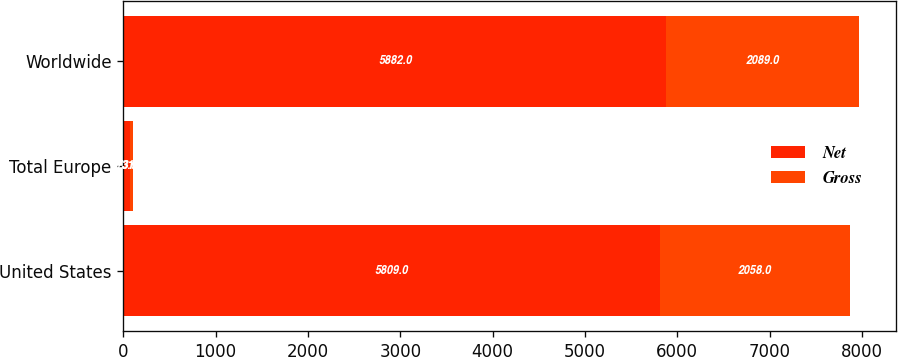Convert chart. <chart><loc_0><loc_0><loc_500><loc_500><stacked_bar_chart><ecel><fcel>United States<fcel>Total Europe<fcel>Worldwide<nl><fcel>Net<fcel>5809<fcel>73<fcel>5882<nl><fcel>Gross<fcel>2058<fcel>31<fcel>2089<nl></chart> 